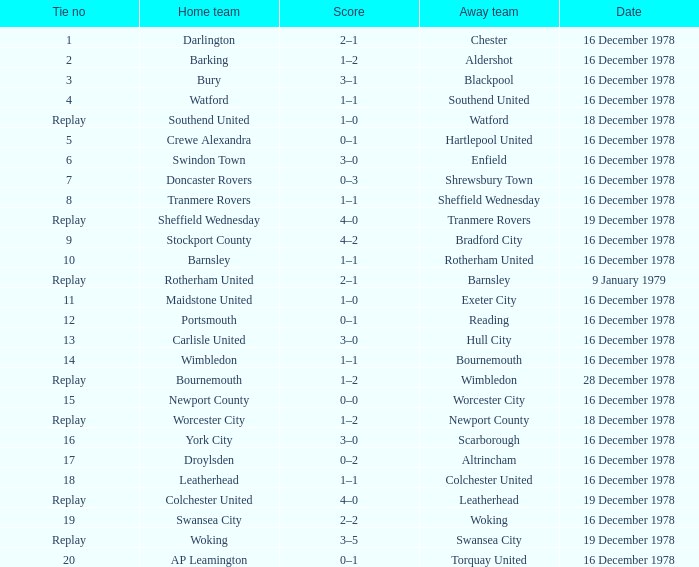What is the number for the tie of the home team swansea city? 19.0. Write the full table. {'header': ['Tie no', 'Home team', 'Score', 'Away team', 'Date'], 'rows': [['1', 'Darlington', '2–1', 'Chester', '16 December 1978'], ['2', 'Barking', '1–2', 'Aldershot', '16 December 1978'], ['3', 'Bury', '3–1', 'Blackpool', '16 December 1978'], ['4', 'Watford', '1–1', 'Southend United', '16 December 1978'], ['Replay', 'Southend United', '1–0', 'Watford', '18 December 1978'], ['5', 'Crewe Alexandra', '0–1', 'Hartlepool United', '16 December 1978'], ['6', 'Swindon Town', '3–0', 'Enfield', '16 December 1978'], ['7', 'Doncaster Rovers', '0–3', 'Shrewsbury Town', '16 December 1978'], ['8', 'Tranmere Rovers', '1–1', 'Sheffield Wednesday', '16 December 1978'], ['Replay', 'Sheffield Wednesday', '4–0', 'Tranmere Rovers', '19 December 1978'], ['9', 'Stockport County', '4–2', 'Bradford City', '16 December 1978'], ['10', 'Barnsley', '1–1', 'Rotherham United', '16 December 1978'], ['Replay', 'Rotherham United', '2–1', 'Barnsley', '9 January 1979'], ['11', 'Maidstone United', '1–0', 'Exeter City', '16 December 1978'], ['12', 'Portsmouth', '0–1', 'Reading', '16 December 1978'], ['13', 'Carlisle United', '3–0', 'Hull City', '16 December 1978'], ['14', 'Wimbledon', '1–1', 'Bournemouth', '16 December 1978'], ['Replay', 'Bournemouth', '1–2', 'Wimbledon', '28 December 1978'], ['15', 'Newport County', '0–0', 'Worcester City', '16 December 1978'], ['Replay', 'Worcester City', '1–2', 'Newport County', '18 December 1978'], ['16', 'York City', '3–0', 'Scarborough', '16 December 1978'], ['17', 'Droylsden', '0–2', 'Altrincham', '16 December 1978'], ['18', 'Leatherhead', '1–1', 'Colchester United', '16 December 1978'], ['Replay', 'Colchester United', '4–0', 'Leatherhead', '19 December 1978'], ['19', 'Swansea City', '2–2', 'Woking', '16 December 1978'], ['Replay', 'Woking', '3–5', 'Swansea City', '19 December 1978'], ['20', 'AP Leamington', '0–1', 'Torquay United', '16 December 1978']]} 